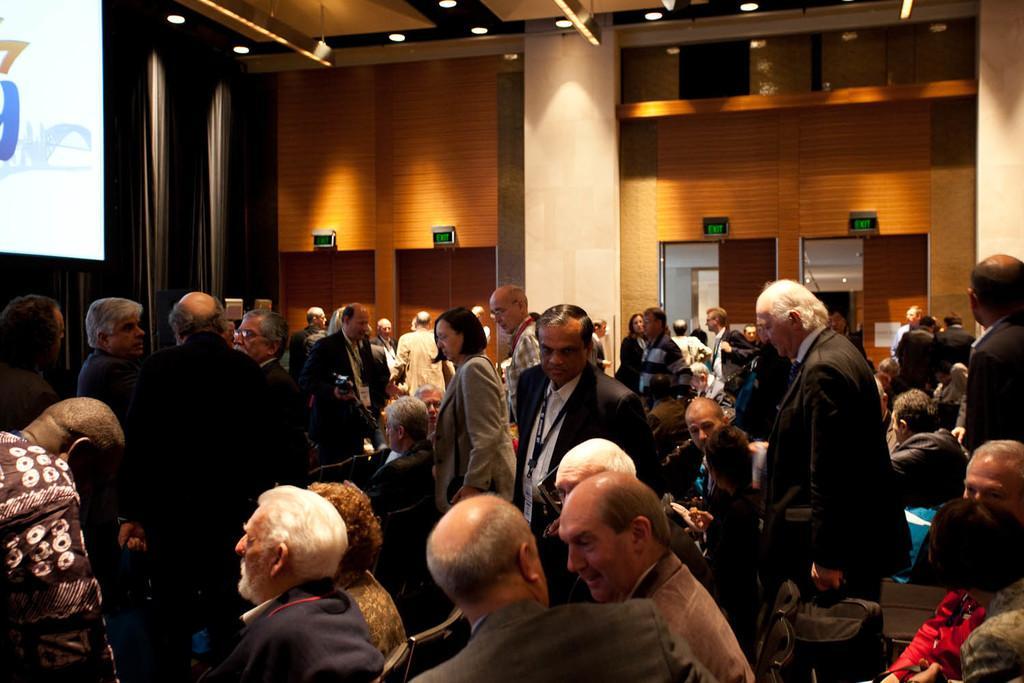Please provide a concise description of this image. In this image I can see group of people, some are sitting and some are standing and I can also see the projection screen. In the background I can see few lights and the wall is in brown color. 